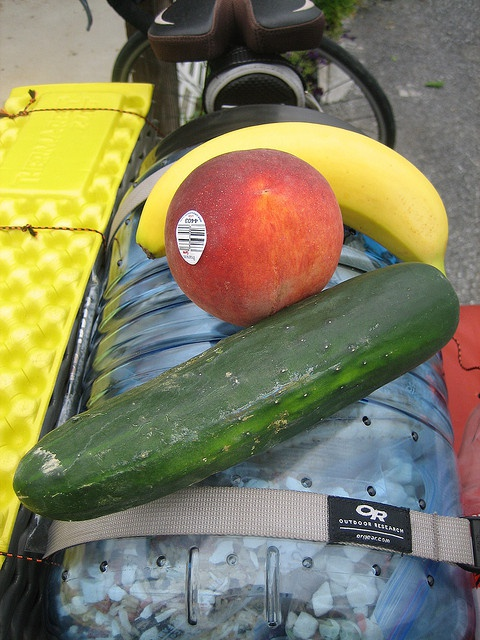Describe the objects in this image and their specific colors. I can see apple in gray, salmon, brown, and red tones and banana in gray, khaki, gold, and olive tones in this image. 